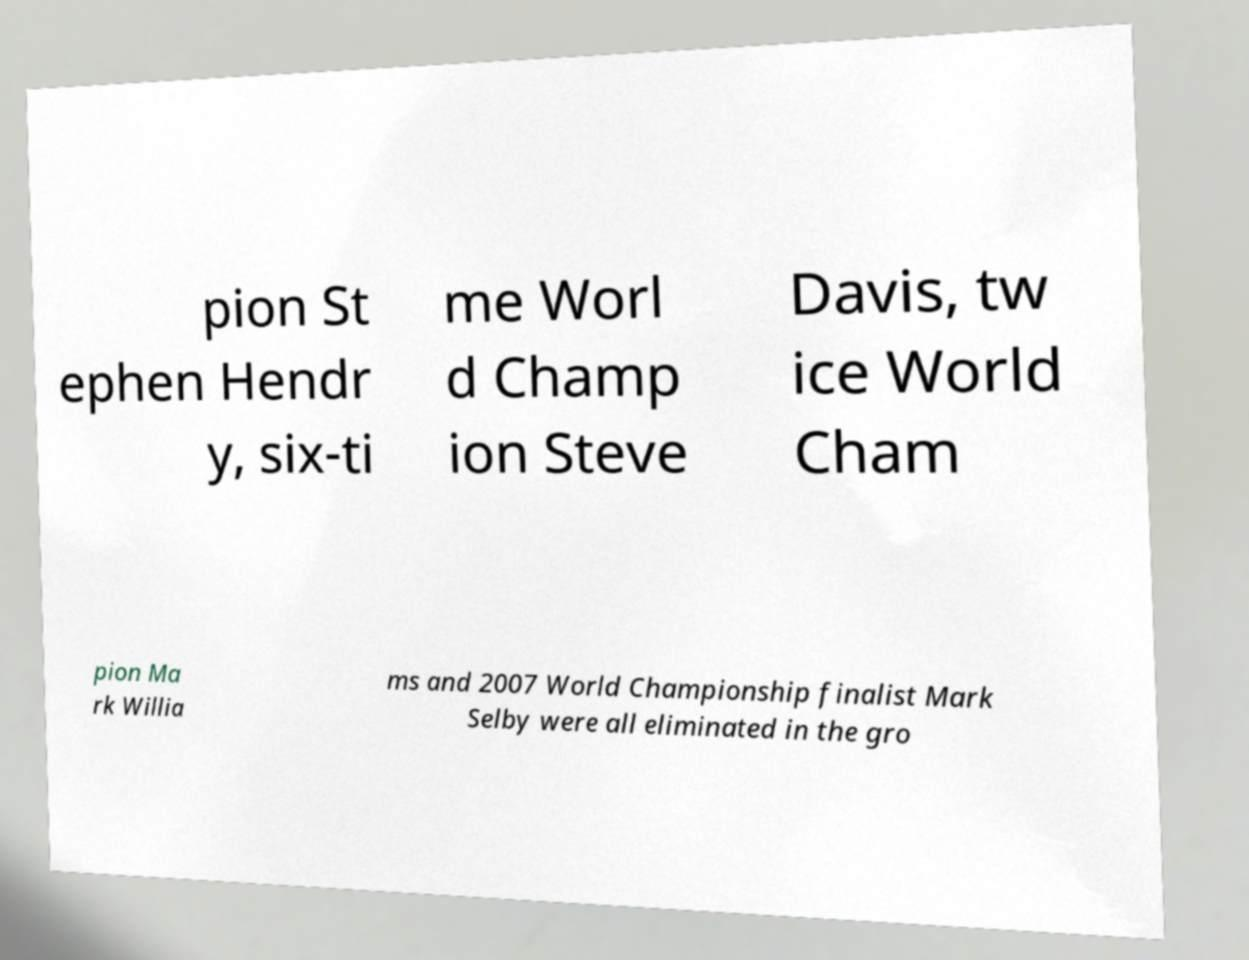Please identify and transcribe the text found in this image. pion St ephen Hendr y, six-ti me Worl d Champ ion Steve Davis, tw ice World Cham pion Ma rk Willia ms and 2007 World Championship finalist Mark Selby were all eliminated in the gro 